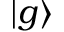Convert formula to latex. <formula><loc_0><loc_0><loc_500><loc_500>| g \rangle</formula> 